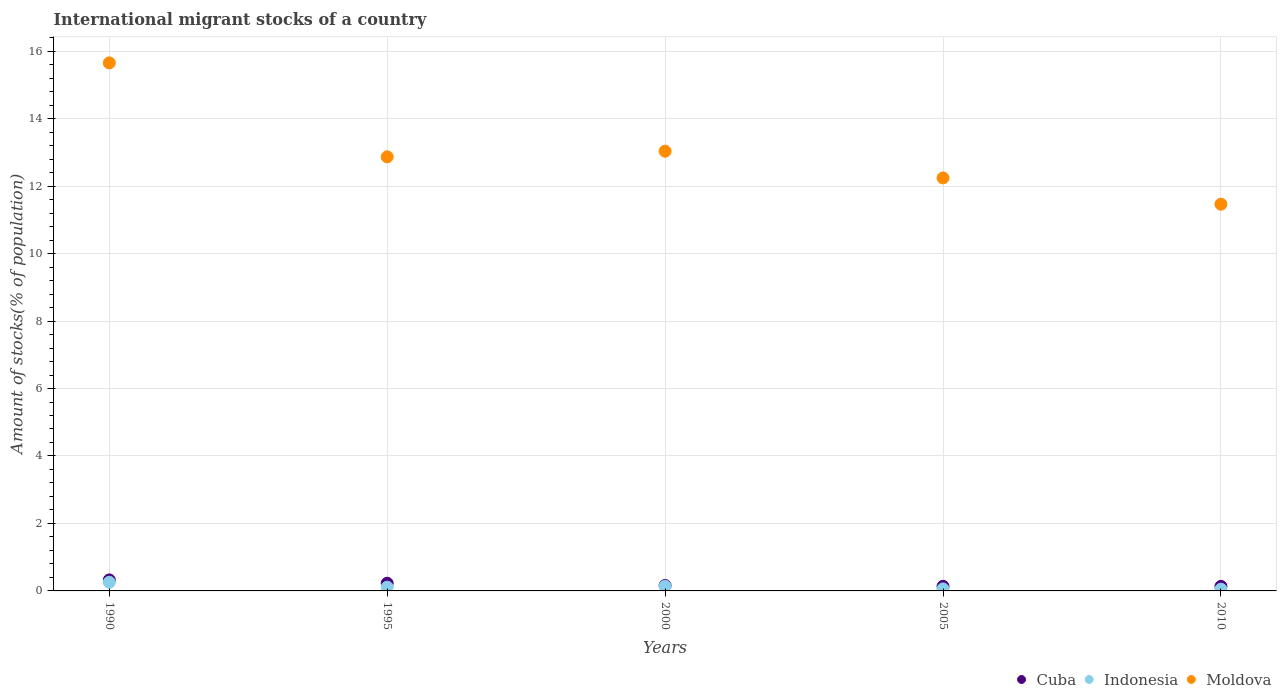Is the number of dotlines equal to the number of legend labels?
Provide a succinct answer. Yes. What is the amount of stocks in in Cuba in 1990?
Keep it short and to the point. 0.33. Across all years, what is the maximum amount of stocks in in Moldova?
Your response must be concise. 15.65. Across all years, what is the minimum amount of stocks in in Cuba?
Your answer should be compact. 0.13. In which year was the amount of stocks in in Moldova maximum?
Ensure brevity in your answer.  1990. In which year was the amount of stocks in in Moldova minimum?
Offer a terse response. 2010. What is the total amount of stocks in in Moldova in the graph?
Provide a short and direct response. 65.26. What is the difference between the amount of stocks in in Indonesia in 1990 and that in 2000?
Ensure brevity in your answer.  0.12. What is the difference between the amount of stocks in in Moldova in 2005 and the amount of stocks in in Indonesia in 2010?
Make the answer very short. 12.19. What is the average amount of stocks in in Moldova per year?
Ensure brevity in your answer.  13.05. In the year 1990, what is the difference between the amount of stocks in in Cuba and amount of stocks in in Indonesia?
Ensure brevity in your answer.  0.07. In how many years, is the amount of stocks in in Indonesia greater than 0.8 %?
Your answer should be compact. 0. What is the ratio of the amount of stocks in in Cuba in 1995 to that in 2000?
Offer a terse response. 1.42. Is the amount of stocks in in Indonesia in 1990 less than that in 1995?
Your answer should be very brief. No. What is the difference between the highest and the second highest amount of stocks in in Moldova?
Make the answer very short. 2.62. What is the difference between the highest and the lowest amount of stocks in in Cuba?
Give a very brief answer. 0.19. In how many years, is the amount of stocks in in Indonesia greater than the average amount of stocks in in Indonesia taken over all years?
Provide a short and direct response. 2. Does the amount of stocks in in Cuba monotonically increase over the years?
Give a very brief answer. No. Is the amount of stocks in in Indonesia strictly greater than the amount of stocks in in Cuba over the years?
Provide a succinct answer. No. Is the amount of stocks in in Moldova strictly less than the amount of stocks in in Indonesia over the years?
Make the answer very short. No. How many dotlines are there?
Your response must be concise. 3. How many years are there in the graph?
Offer a terse response. 5. Does the graph contain any zero values?
Your answer should be compact. No. Does the graph contain grids?
Keep it short and to the point. Yes. How many legend labels are there?
Your response must be concise. 3. What is the title of the graph?
Make the answer very short. International migrant stocks of a country. What is the label or title of the X-axis?
Keep it short and to the point. Years. What is the label or title of the Y-axis?
Your answer should be very brief. Amount of stocks(% of population). What is the Amount of stocks(% of population) in Cuba in 1990?
Provide a succinct answer. 0.33. What is the Amount of stocks(% of population) in Indonesia in 1990?
Your answer should be very brief. 0.26. What is the Amount of stocks(% of population) of Moldova in 1990?
Offer a very short reply. 15.65. What is the Amount of stocks(% of population) of Cuba in 1995?
Make the answer very short. 0.23. What is the Amount of stocks(% of population) of Indonesia in 1995?
Offer a very short reply. 0.11. What is the Amount of stocks(% of population) of Moldova in 1995?
Make the answer very short. 12.87. What is the Amount of stocks(% of population) of Cuba in 2000?
Ensure brevity in your answer.  0.16. What is the Amount of stocks(% of population) of Indonesia in 2000?
Offer a terse response. 0.14. What is the Amount of stocks(% of population) in Moldova in 2000?
Provide a short and direct response. 13.03. What is the Amount of stocks(% of population) of Cuba in 2005?
Your response must be concise. 0.14. What is the Amount of stocks(% of population) of Indonesia in 2005?
Ensure brevity in your answer.  0.06. What is the Amount of stocks(% of population) of Moldova in 2005?
Your response must be concise. 12.24. What is the Amount of stocks(% of population) in Cuba in 2010?
Make the answer very short. 0.13. What is the Amount of stocks(% of population) in Indonesia in 2010?
Provide a succinct answer. 0.05. What is the Amount of stocks(% of population) in Moldova in 2010?
Your answer should be compact. 11.46. Across all years, what is the maximum Amount of stocks(% of population) in Cuba?
Provide a succinct answer. 0.33. Across all years, what is the maximum Amount of stocks(% of population) in Indonesia?
Provide a short and direct response. 0.26. Across all years, what is the maximum Amount of stocks(% of population) in Moldova?
Provide a short and direct response. 15.65. Across all years, what is the minimum Amount of stocks(% of population) of Cuba?
Ensure brevity in your answer.  0.13. Across all years, what is the minimum Amount of stocks(% of population) of Indonesia?
Make the answer very short. 0.05. Across all years, what is the minimum Amount of stocks(% of population) in Moldova?
Ensure brevity in your answer.  11.46. What is the total Amount of stocks(% of population) in Cuba in the graph?
Provide a succinct answer. 0.99. What is the total Amount of stocks(% of population) of Indonesia in the graph?
Keep it short and to the point. 0.62. What is the total Amount of stocks(% of population) in Moldova in the graph?
Offer a terse response. 65.26. What is the difference between the Amount of stocks(% of population) of Cuba in 1990 and that in 1995?
Your response must be concise. 0.1. What is the difference between the Amount of stocks(% of population) in Indonesia in 1990 and that in 1995?
Keep it short and to the point. 0.15. What is the difference between the Amount of stocks(% of population) of Moldova in 1990 and that in 1995?
Your answer should be very brief. 2.78. What is the difference between the Amount of stocks(% of population) of Cuba in 1990 and that in 2000?
Your response must be concise. 0.17. What is the difference between the Amount of stocks(% of population) of Indonesia in 1990 and that in 2000?
Keep it short and to the point. 0.12. What is the difference between the Amount of stocks(% of population) in Moldova in 1990 and that in 2000?
Provide a succinct answer. 2.62. What is the difference between the Amount of stocks(% of population) of Cuba in 1990 and that in 2005?
Give a very brief answer. 0.19. What is the difference between the Amount of stocks(% of population) in Indonesia in 1990 and that in 2005?
Your response must be concise. 0.2. What is the difference between the Amount of stocks(% of population) in Moldova in 1990 and that in 2005?
Make the answer very short. 3.41. What is the difference between the Amount of stocks(% of population) of Cuba in 1990 and that in 2010?
Offer a very short reply. 0.19. What is the difference between the Amount of stocks(% of population) in Indonesia in 1990 and that in 2010?
Your response must be concise. 0.21. What is the difference between the Amount of stocks(% of population) of Moldova in 1990 and that in 2010?
Provide a short and direct response. 4.19. What is the difference between the Amount of stocks(% of population) of Cuba in 1995 and that in 2000?
Your answer should be very brief. 0.07. What is the difference between the Amount of stocks(% of population) of Indonesia in 1995 and that in 2000?
Provide a short and direct response. -0.03. What is the difference between the Amount of stocks(% of population) of Cuba in 1995 and that in 2005?
Offer a terse response. 0.09. What is the difference between the Amount of stocks(% of population) in Indonesia in 1995 and that in 2005?
Offer a terse response. 0.05. What is the difference between the Amount of stocks(% of population) of Moldova in 1995 and that in 2005?
Give a very brief answer. 0.63. What is the difference between the Amount of stocks(% of population) of Cuba in 1995 and that in 2010?
Keep it short and to the point. 0.09. What is the difference between the Amount of stocks(% of population) of Indonesia in 1995 and that in 2010?
Offer a terse response. 0.06. What is the difference between the Amount of stocks(% of population) of Moldova in 1995 and that in 2010?
Provide a succinct answer. 1.4. What is the difference between the Amount of stocks(% of population) in Cuba in 2000 and that in 2005?
Keep it short and to the point. 0.02. What is the difference between the Amount of stocks(% of population) in Indonesia in 2000 and that in 2005?
Offer a very short reply. 0.08. What is the difference between the Amount of stocks(% of population) in Moldova in 2000 and that in 2005?
Your response must be concise. 0.79. What is the difference between the Amount of stocks(% of population) of Cuba in 2000 and that in 2010?
Offer a very short reply. 0.03. What is the difference between the Amount of stocks(% of population) of Indonesia in 2000 and that in 2010?
Your answer should be compact. 0.09. What is the difference between the Amount of stocks(% of population) in Moldova in 2000 and that in 2010?
Provide a succinct answer. 1.57. What is the difference between the Amount of stocks(% of population) of Cuba in 2005 and that in 2010?
Make the answer very short. 0. What is the difference between the Amount of stocks(% of population) of Indonesia in 2005 and that in 2010?
Your answer should be very brief. 0.01. What is the difference between the Amount of stocks(% of population) of Moldova in 2005 and that in 2010?
Give a very brief answer. 0.78. What is the difference between the Amount of stocks(% of population) in Cuba in 1990 and the Amount of stocks(% of population) in Indonesia in 1995?
Your answer should be compact. 0.22. What is the difference between the Amount of stocks(% of population) of Cuba in 1990 and the Amount of stocks(% of population) of Moldova in 1995?
Your answer should be very brief. -12.54. What is the difference between the Amount of stocks(% of population) in Indonesia in 1990 and the Amount of stocks(% of population) in Moldova in 1995?
Make the answer very short. -12.61. What is the difference between the Amount of stocks(% of population) in Cuba in 1990 and the Amount of stocks(% of population) in Indonesia in 2000?
Ensure brevity in your answer.  0.19. What is the difference between the Amount of stocks(% of population) in Cuba in 1990 and the Amount of stocks(% of population) in Moldova in 2000?
Provide a short and direct response. -12.71. What is the difference between the Amount of stocks(% of population) in Indonesia in 1990 and the Amount of stocks(% of population) in Moldova in 2000?
Your answer should be very brief. -12.78. What is the difference between the Amount of stocks(% of population) in Cuba in 1990 and the Amount of stocks(% of population) in Indonesia in 2005?
Offer a very short reply. 0.27. What is the difference between the Amount of stocks(% of population) in Cuba in 1990 and the Amount of stocks(% of population) in Moldova in 2005?
Your response must be concise. -11.92. What is the difference between the Amount of stocks(% of population) in Indonesia in 1990 and the Amount of stocks(% of population) in Moldova in 2005?
Your response must be concise. -11.99. What is the difference between the Amount of stocks(% of population) in Cuba in 1990 and the Amount of stocks(% of population) in Indonesia in 2010?
Offer a terse response. 0.28. What is the difference between the Amount of stocks(% of population) in Cuba in 1990 and the Amount of stocks(% of population) in Moldova in 2010?
Provide a short and direct response. -11.14. What is the difference between the Amount of stocks(% of population) in Indonesia in 1990 and the Amount of stocks(% of population) in Moldova in 2010?
Keep it short and to the point. -11.21. What is the difference between the Amount of stocks(% of population) of Cuba in 1995 and the Amount of stocks(% of population) of Indonesia in 2000?
Keep it short and to the point. 0.09. What is the difference between the Amount of stocks(% of population) in Cuba in 1995 and the Amount of stocks(% of population) in Moldova in 2000?
Your answer should be compact. -12.81. What is the difference between the Amount of stocks(% of population) of Indonesia in 1995 and the Amount of stocks(% of population) of Moldova in 2000?
Offer a terse response. -12.92. What is the difference between the Amount of stocks(% of population) in Cuba in 1995 and the Amount of stocks(% of population) in Indonesia in 2005?
Provide a short and direct response. 0.17. What is the difference between the Amount of stocks(% of population) in Cuba in 1995 and the Amount of stocks(% of population) in Moldova in 2005?
Offer a terse response. -12.01. What is the difference between the Amount of stocks(% of population) in Indonesia in 1995 and the Amount of stocks(% of population) in Moldova in 2005?
Provide a short and direct response. -12.13. What is the difference between the Amount of stocks(% of population) of Cuba in 1995 and the Amount of stocks(% of population) of Indonesia in 2010?
Ensure brevity in your answer.  0.18. What is the difference between the Amount of stocks(% of population) of Cuba in 1995 and the Amount of stocks(% of population) of Moldova in 2010?
Offer a terse response. -11.24. What is the difference between the Amount of stocks(% of population) of Indonesia in 1995 and the Amount of stocks(% of population) of Moldova in 2010?
Make the answer very short. -11.35. What is the difference between the Amount of stocks(% of population) in Cuba in 2000 and the Amount of stocks(% of population) in Indonesia in 2005?
Your answer should be compact. 0.1. What is the difference between the Amount of stocks(% of population) in Cuba in 2000 and the Amount of stocks(% of population) in Moldova in 2005?
Give a very brief answer. -12.08. What is the difference between the Amount of stocks(% of population) in Indonesia in 2000 and the Amount of stocks(% of population) in Moldova in 2005?
Keep it short and to the point. -12.1. What is the difference between the Amount of stocks(% of population) in Cuba in 2000 and the Amount of stocks(% of population) in Indonesia in 2010?
Provide a short and direct response. 0.11. What is the difference between the Amount of stocks(% of population) of Cuba in 2000 and the Amount of stocks(% of population) of Moldova in 2010?
Make the answer very short. -11.3. What is the difference between the Amount of stocks(% of population) of Indonesia in 2000 and the Amount of stocks(% of population) of Moldova in 2010?
Your answer should be compact. -11.32. What is the difference between the Amount of stocks(% of population) of Cuba in 2005 and the Amount of stocks(% of population) of Indonesia in 2010?
Your answer should be very brief. 0.09. What is the difference between the Amount of stocks(% of population) of Cuba in 2005 and the Amount of stocks(% of population) of Moldova in 2010?
Make the answer very short. -11.33. What is the difference between the Amount of stocks(% of population) of Indonesia in 2005 and the Amount of stocks(% of population) of Moldova in 2010?
Ensure brevity in your answer.  -11.4. What is the average Amount of stocks(% of population) in Cuba per year?
Your answer should be compact. 0.2. What is the average Amount of stocks(% of population) of Indonesia per year?
Your response must be concise. 0.12. What is the average Amount of stocks(% of population) of Moldova per year?
Keep it short and to the point. 13.05. In the year 1990, what is the difference between the Amount of stocks(% of population) in Cuba and Amount of stocks(% of population) in Indonesia?
Give a very brief answer. 0.07. In the year 1990, what is the difference between the Amount of stocks(% of population) in Cuba and Amount of stocks(% of population) in Moldova?
Provide a short and direct response. -15.33. In the year 1990, what is the difference between the Amount of stocks(% of population) of Indonesia and Amount of stocks(% of population) of Moldova?
Ensure brevity in your answer.  -15.4. In the year 1995, what is the difference between the Amount of stocks(% of population) of Cuba and Amount of stocks(% of population) of Indonesia?
Offer a very short reply. 0.12. In the year 1995, what is the difference between the Amount of stocks(% of population) of Cuba and Amount of stocks(% of population) of Moldova?
Give a very brief answer. -12.64. In the year 1995, what is the difference between the Amount of stocks(% of population) of Indonesia and Amount of stocks(% of population) of Moldova?
Ensure brevity in your answer.  -12.76. In the year 2000, what is the difference between the Amount of stocks(% of population) of Cuba and Amount of stocks(% of population) of Indonesia?
Your answer should be very brief. 0.02. In the year 2000, what is the difference between the Amount of stocks(% of population) of Cuba and Amount of stocks(% of population) of Moldova?
Your answer should be compact. -12.87. In the year 2000, what is the difference between the Amount of stocks(% of population) in Indonesia and Amount of stocks(% of population) in Moldova?
Make the answer very short. -12.9. In the year 2005, what is the difference between the Amount of stocks(% of population) in Cuba and Amount of stocks(% of population) in Indonesia?
Keep it short and to the point. 0.08. In the year 2005, what is the difference between the Amount of stocks(% of population) of Cuba and Amount of stocks(% of population) of Moldova?
Provide a succinct answer. -12.11. In the year 2005, what is the difference between the Amount of stocks(% of population) in Indonesia and Amount of stocks(% of population) in Moldova?
Provide a short and direct response. -12.18. In the year 2010, what is the difference between the Amount of stocks(% of population) of Cuba and Amount of stocks(% of population) of Indonesia?
Your response must be concise. 0.08. In the year 2010, what is the difference between the Amount of stocks(% of population) in Cuba and Amount of stocks(% of population) in Moldova?
Provide a succinct answer. -11.33. In the year 2010, what is the difference between the Amount of stocks(% of population) of Indonesia and Amount of stocks(% of population) of Moldova?
Give a very brief answer. -11.41. What is the ratio of the Amount of stocks(% of population) in Cuba in 1990 to that in 1995?
Your response must be concise. 1.44. What is the ratio of the Amount of stocks(% of population) of Indonesia in 1990 to that in 1995?
Give a very brief answer. 2.31. What is the ratio of the Amount of stocks(% of population) of Moldova in 1990 to that in 1995?
Offer a very short reply. 1.22. What is the ratio of the Amount of stocks(% of population) in Cuba in 1990 to that in 2000?
Give a very brief answer. 2.04. What is the ratio of the Amount of stocks(% of population) in Indonesia in 1990 to that in 2000?
Keep it short and to the point. 1.86. What is the ratio of the Amount of stocks(% of population) of Moldova in 1990 to that in 2000?
Your response must be concise. 1.2. What is the ratio of the Amount of stocks(% of population) in Cuba in 1990 to that in 2005?
Provide a succinct answer. 2.4. What is the ratio of the Amount of stocks(% of population) in Indonesia in 1990 to that in 2005?
Offer a terse response. 4.28. What is the ratio of the Amount of stocks(% of population) of Moldova in 1990 to that in 2005?
Offer a very short reply. 1.28. What is the ratio of the Amount of stocks(% of population) of Cuba in 1990 to that in 2010?
Provide a short and direct response. 2.42. What is the ratio of the Amount of stocks(% of population) of Indonesia in 1990 to that in 2010?
Offer a very short reply. 5.04. What is the ratio of the Amount of stocks(% of population) of Moldova in 1990 to that in 2010?
Give a very brief answer. 1.37. What is the ratio of the Amount of stocks(% of population) of Cuba in 1995 to that in 2000?
Offer a terse response. 1.42. What is the ratio of the Amount of stocks(% of population) in Indonesia in 1995 to that in 2000?
Give a very brief answer. 0.81. What is the ratio of the Amount of stocks(% of population) of Moldova in 1995 to that in 2000?
Your answer should be very brief. 0.99. What is the ratio of the Amount of stocks(% of population) of Cuba in 1995 to that in 2005?
Give a very brief answer. 1.67. What is the ratio of the Amount of stocks(% of population) of Indonesia in 1995 to that in 2005?
Your response must be concise. 1.86. What is the ratio of the Amount of stocks(% of population) in Moldova in 1995 to that in 2005?
Provide a short and direct response. 1.05. What is the ratio of the Amount of stocks(% of population) of Cuba in 1995 to that in 2010?
Your answer should be compact. 1.69. What is the ratio of the Amount of stocks(% of population) of Indonesia in 1995 to that in 2010?
Your answer should be compact. 2.19. What is the ratio of the Amount of stocks(% of population) of Moldova in 1995 to that in 2010?
Offer a very short reply. 1.12. What is the ratio of the Amount of stocks(% of population) of Cuba in 2000 to that in 2005?
Provide a short and direct response. 1.18. What is the ratio of the Amount of stocks(% of population) in Indonesia in 2000 to that in 2005?
Ensure brevity in your answer.  2.31. What is the ratio of the Amount of stocks(% of population) in Moldova in 2000 to that in 2005?
Offer a terse response. 1.06. What is the ratio of the Amount of stocks(% of population) of Cuba in 2000 to that in 2010?
Make the answer very short. 1.19. What is the ratio of the Amount of stocks(% of population) in Indonesia in 2000 to that in 2010?
Provide a short and direct response. 2.72. What is the ratio of the Amount of stocks(% of population) of Moldova in 2000 to that in 2010?
Offer a terse response. 1.14. What is the ratio of the Amount of stocks(% of population) of Cuba in 2005 to that in 2010?
Your answer should be very brief. 1.01. What is the ratio of the Amount of stocks(% of population) in Indonesia in 2005 to that in 2010?
Ensure brevity in your answer.  1.18. What is the ratio of the Amount of stocks(% of population) of Moldova in 2005 to that in 2010?
Make the answer very short. 1.07. What is the difference between the highest and the second highest Amount of stocks(% of population) in Cuba?
Give a very brief answer. 0.1. What is the difference between the highest and the second highest Amount of stocks(% of population) of Indonesia?
Give a very brief answer. 0.12. What is the difference between the highest and the second highest Amount of stocks(% of population) of Moldova?
Keep it short and to the point. 2.62. What is the difference between the highest and the lowest Amount of stocks(% of population) in Cuba?
Your response must be concise. 0.19. What is the difference between the highest and the lowest Amount of stocks(% of population) in Indonesia?
Provide a short and direct response. 0.21. What is the difference between the highest and the lowest Amount of stocks(% of population) in Moldova?
Keep it short and to the point. 4.19. 